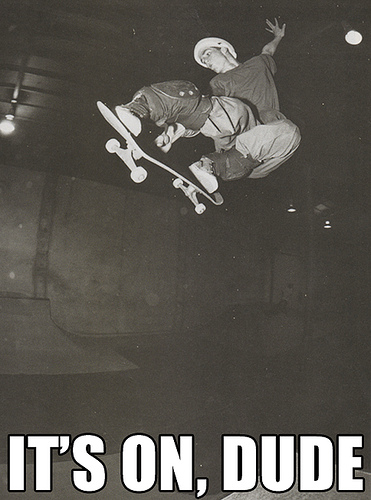Please extract the text content from this image. IT'S ON DUDE 